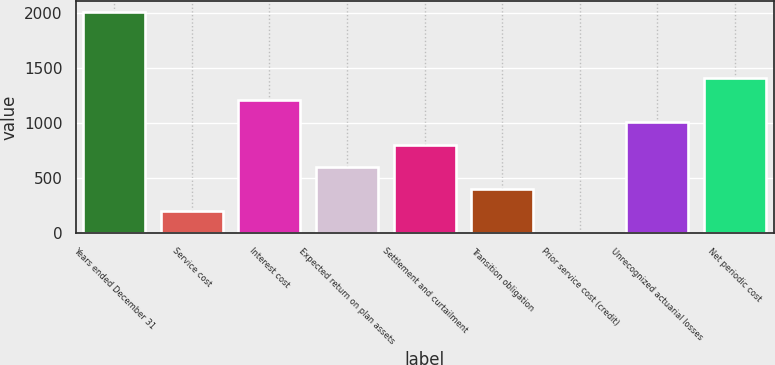<chart> <loc_0><loc_0><loc_500><loc_500><bar_chart><fcel>Years ended December 31<fcel>Service cost<fcel>Interest cost<fcel>Expected return on plan assets<fcel>Settlement and curtailment<fcel>Transition obligation<fcel>Prior service cost (credit)<fcel>Unrecognized actuarial losses<fcel>Net periodic cost<nl><fcel>2012<fcel>201.29<fcel>1207.24<fcel>603.67<fcel>804.86<fcel>402.48<fcel>0.1<fcel>1006.05<fcel>1408.43<nl></chart> 